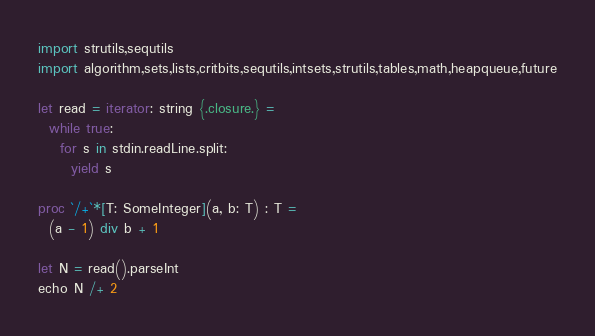Convert code to text. <code><loc_0><loc_0><loc_500><loc_500><_Nim_>import strutils,sequtils
import algorithm,sets,lists,critbits,sequtils,intsets,strutils,tables,math,heapqueue,future

let read = iterator: string {.closure.} =
  while true:
    for s in stdin.readLine.split:
      yield s

proc `/+`*[T: SomeInteger](a, b: T) : T =
  (a - 1) div b + 1

let N = read().parseInt
echo N /+ 2
</code> 